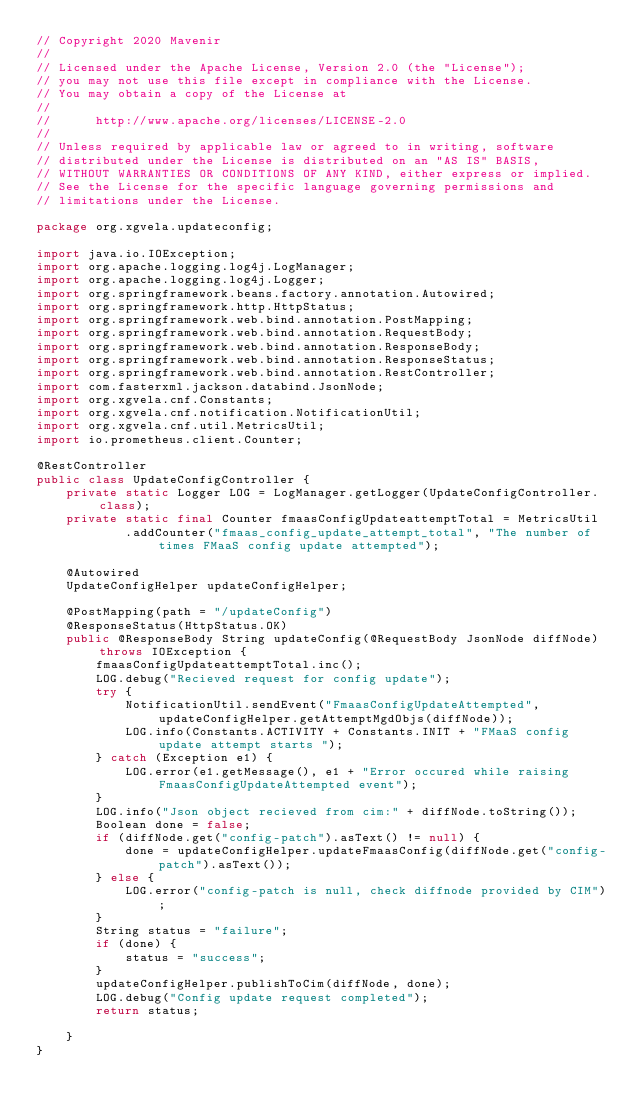Convert code to text. <code><loc_0><loc_0><loc_500><loc_500><_Java_>// Copyright 2020 Mavenir
//
// Licensed under the Apache License, Version 2.0 (the "License");
// you may not use this file except in compliance with the License.
// You may obtain a copy of the License at
//
//      http://www.apache.org/licenses/LICENSE-2.0
//
// Unless required by applicable law or agreed to in writing, software
// distributed under the License is distributed on an "AS IS" BASIS,
// WITHOUT WARRANTIES OR CONDITIONS OF ANY KIND, either express or implied.
// See the License for the specific language governing permissions and
// limitations under the License.

package org.xgvela.updateconfig;

import java.io.IOException;
import org.apache.logging.log4j.LogManager;
import org.apache.logging.log4j.Logger;
import org.springframework.beans.factory.annotation.Autowired;
import org.springframework.http.HttpStatus;
import org.springframework.web.bind.annotation.PostMapping;
import org.springframework.web.bind.annotation.RequestBody;
import org.springframework.web.bind.annotation.ResponseBody;
import org.springframework.web.bind.annotation.ResponseStatus;
import org.springframework.web.bind.annotation.RestController;
import com.fasterxml.jackson.databind.JsonNode;
import org.xgvela.cnf.Constants;
import org.xgvela.cnf.notification.NotificationUtil;
import org.xgvela.cnf.util.MetricsUtil;
import io.prometheus.client.Counter;

@RestController
public class UpdateConfigController {
	private static Logger LOG = LogManager.getLogger(UpdateConfigController.class);
	private static final Counter fmaasConfigUpdateattemptTotal = MetricsUtil
			.addCounter("fmaas_config_update_attempt_total", "The number of times FMaaS config update attempted");

	@Autowired
	UpdateConfigHelper updateConfigHelper;

	@PostMapping(path = "/updateConfig")
	@ResponseStatus(HttpStatus.OK)
	public @ResponseBody String updateConfig(@RequestBody JsonNode diffNode) throws IOException {
		fmaasConfigUpdateattemptTotal.inc();
		LOG.debug("Recieved request for config update");
		try {
			NotificationUtil.sendEvent("FmaasConfigUpdateAttempted", updateConfigHelper.getAttemptMgdObjs(diffNode));
			LOG.info(Constants.ACTIVITY + Constants.INIT + "FMaaS config update attempt starts ");
		} catch (Exception e1) {
			LOG.error(e1.getMessage(), e1 + "Error occured while raising FmaasConfigUpdateAttempted event");
		}
		LOG.info("Json object recieved from cim:" + diffNode.toString());
		Boolean done = false;
		if (diffNode.get("config-patch").asText() != null) {
			done = updateConfigHelper.updateFmaasConfig(diffNode.get("config-patch").asText());
		} else {
			LOG.error("config-patch is null, check diffnode provided by CIM");
		}
		String status = "failure";
		if (done) {
			status = "success";
		}
		updateConfigHelper.publishToCim(diffNode, done);
		LOG.debug("Config update request completed");
		return status;

	}
}
</code> 